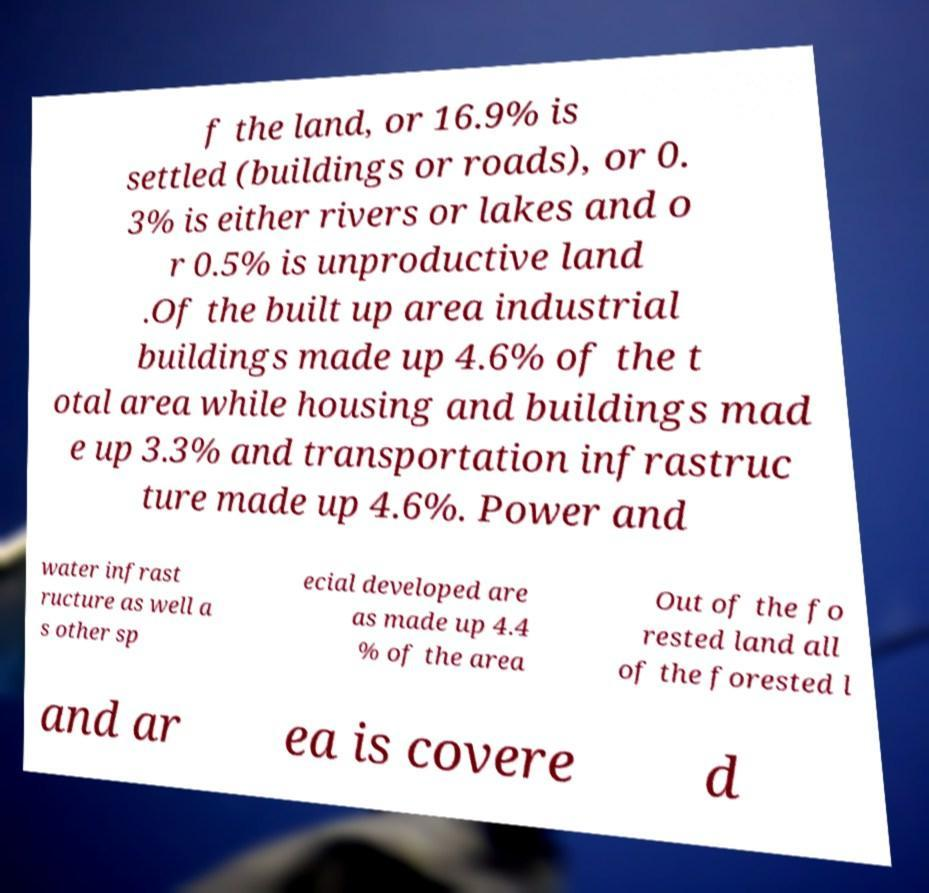Please read and relay the text visible in this image. What does it say? f the land, or 16.9% is settled (buildings or roads), or 0. 3% is either rivers or lakes and o r 0.5% is unproductive land .Of the built up area industrial buildings made up 4.6% of the t otal area while housing and buildings mad e up 3.3% and transportation infrastruc ture made up 4.6%. Power and water infrast ructure as well a s other sp ecial developed are as made up 4.4 % of the area Out of the fo rested land all of the forested l and ar ea is covere d 